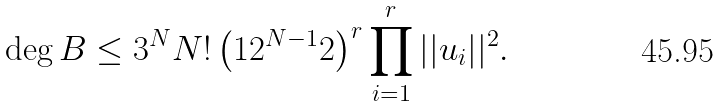Convert formula to latex. <formula><loc_0><loc_0><loc_500><loc_500>\deg B \leq 3 ^ { N } N ! \left ( 1 2 ^ { N - 1 } 2 \right ) ^ { r } \prod _ { i = 1 } ^ { r } | | u _ { i } | | ^ { 2 } .</formula> 